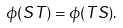<formula> <loc_0><loc_0><loc_500><loc_500>\phi ( S T ) = \phi ( T S ) .</formula> 